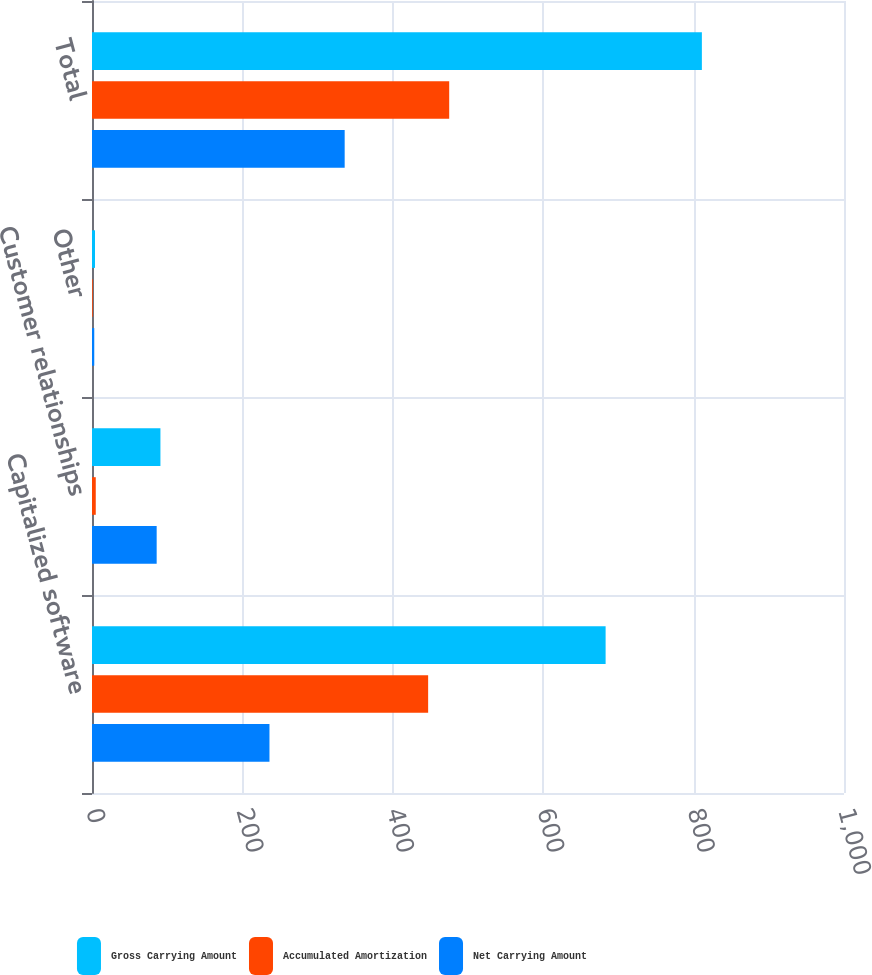Convert chart. <chart><loc_0><loc_0><loc_500><loc_500><stacked_bar_chart><ecel><fcel>Capitalized software<fcel>Customer relationships<fcel>Other<fcel>Total<nl><fcel>Gross Carrying Amount<fcel>683<fcel>91<fcel>4<fcel>811<nl><fcel>Accumulated Amortization<fcel>447<fcel>5<fcel>1<fcel>475<nl><fcel>Net Carrying Amount<fcel>236<fcel>86<fcel>3<fcel>336<nl></chart> 